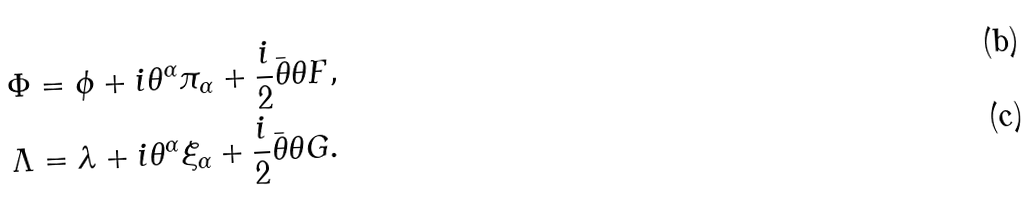<formula> <loc_0><loc_0><loc_500><loc_500>\Phi & = \phi + i \theta ^ { \alpha } \pi _ { \alpha } + \frac { i } { 2 } \bar { \theta } \theta F , \\ \Lambda & = \lambda + i \theta ^ { \alpha } \xi _ { \alpha } + \frac { i } { 2 } \bar { \theta } \theta G .</formula> 